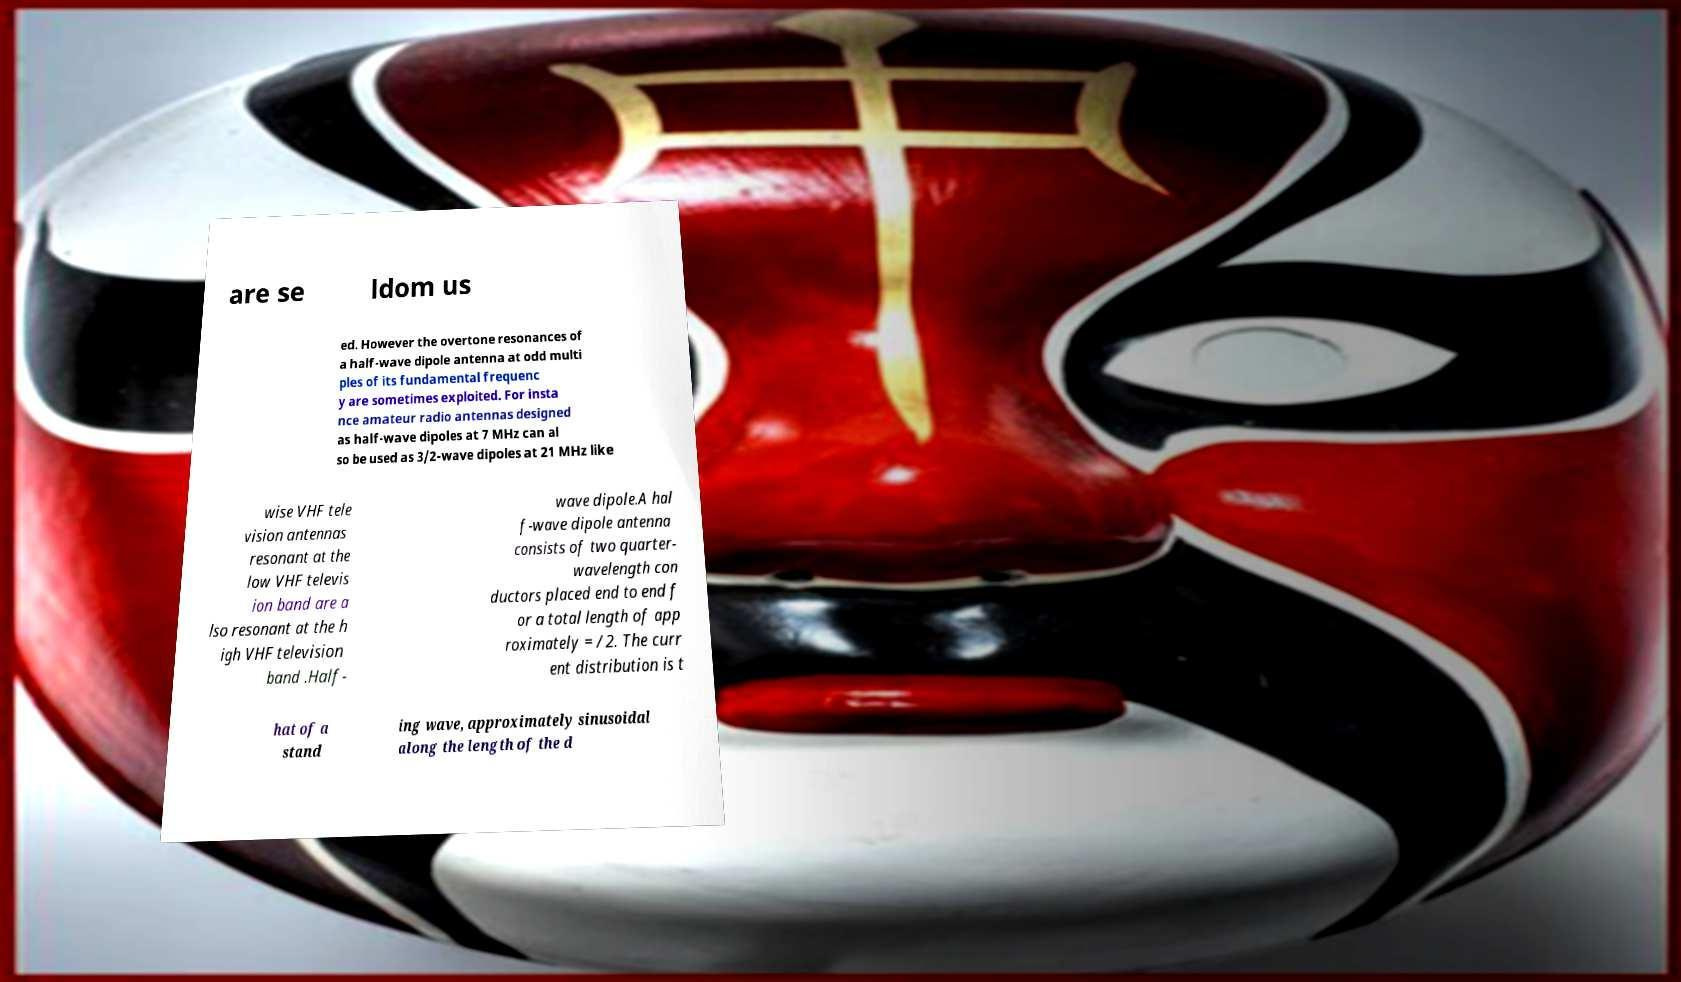What messages or text are displayed in this image? I need them in a readable, typed format. are se ldom us ed. However the overtone resonances of a half-wave dipole antenna at odd multi ples of its fundamental frequenc y are sometimes exploited. For insta nce amateur radio antennas designed as half-wave dipoles at 7 MHz can al so be used as 3/2-wave dipoles at 21 MHz like wise VHF tele vision antennas resonant at the low VHF televis ion band are a lso resonant at the h igh VHF television band .Half- wave dipole.A hal f-wave dipole antenna consists of two quarter- wavelength con ductors placed end to end f or a total length of app roximately = /2. The curr ent distribution is t hat of a stand ing wave, approximately sinusoidal along the length of the d 